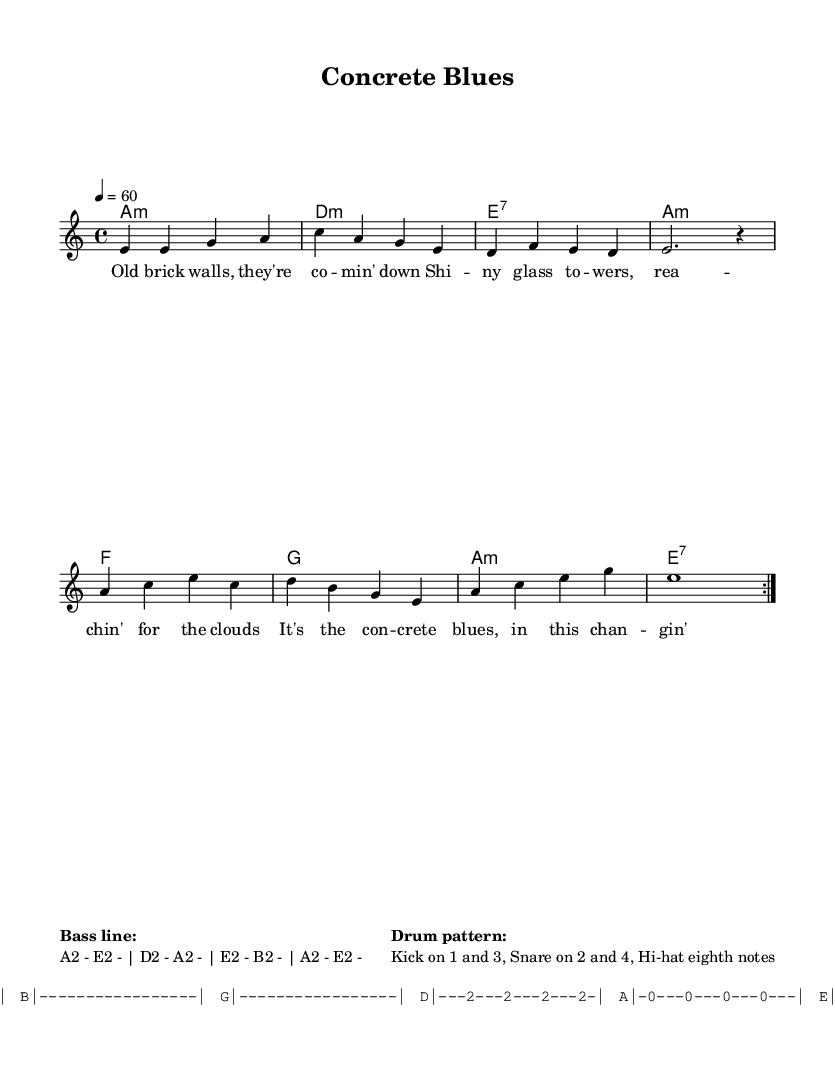What is the key signature of this music? The key signature of the piece is A minor, which is indicated at the beginning of the sheet music. A minor has no sharps or flats.
Answer: A minor What is the time signature of the music? The time signature is 4/4, shown at the beginning of the score. This means there are four beats in each measure and the quarter note gets one beat.
Answer: 4/4 What is the tempo of the piece? The tempo is marked as 60 beats per minute, indicated in the score as "4 = 60." This indicates the speed at which the piece should be played.
Answer: 60 How many measures are repeated in the melody? The melody has a repeated section which is indicated by "volta 2" after the first half of the melody, meaning the first part is played two times.
Answer: Two What is the primary theme of the lyrics? The lyrics reflect on urban development and the effects of gentrification, addressing topics like rising rents and changing landscapes in the city.
Answer: Urban development and gentrification What is the chord progression in the first line? The first line's chord progression is A minor, D minor, E7, A minor. These chords provide the harmonic foundation for the melody.
Answer: A minor, D minor, E7, A minor What genre does this tune belong to? The piece is classified as a Blues tune, with a soulful character that is common in the Blues music genre, emphasizing emotional themes such as struggle and change.
Answer: Blues 